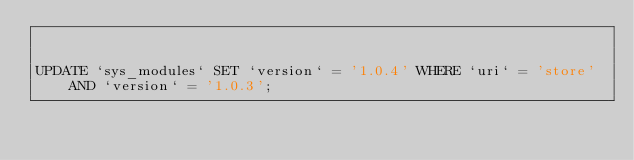<code> <loc_0><loc_0><loc_500><loc_500><_SQL_>

UPDATE `sys_modules` SET `version` = '1.0.4' WHERE `uri` = 'store' AND `version` = '1.0.3';

</code> 